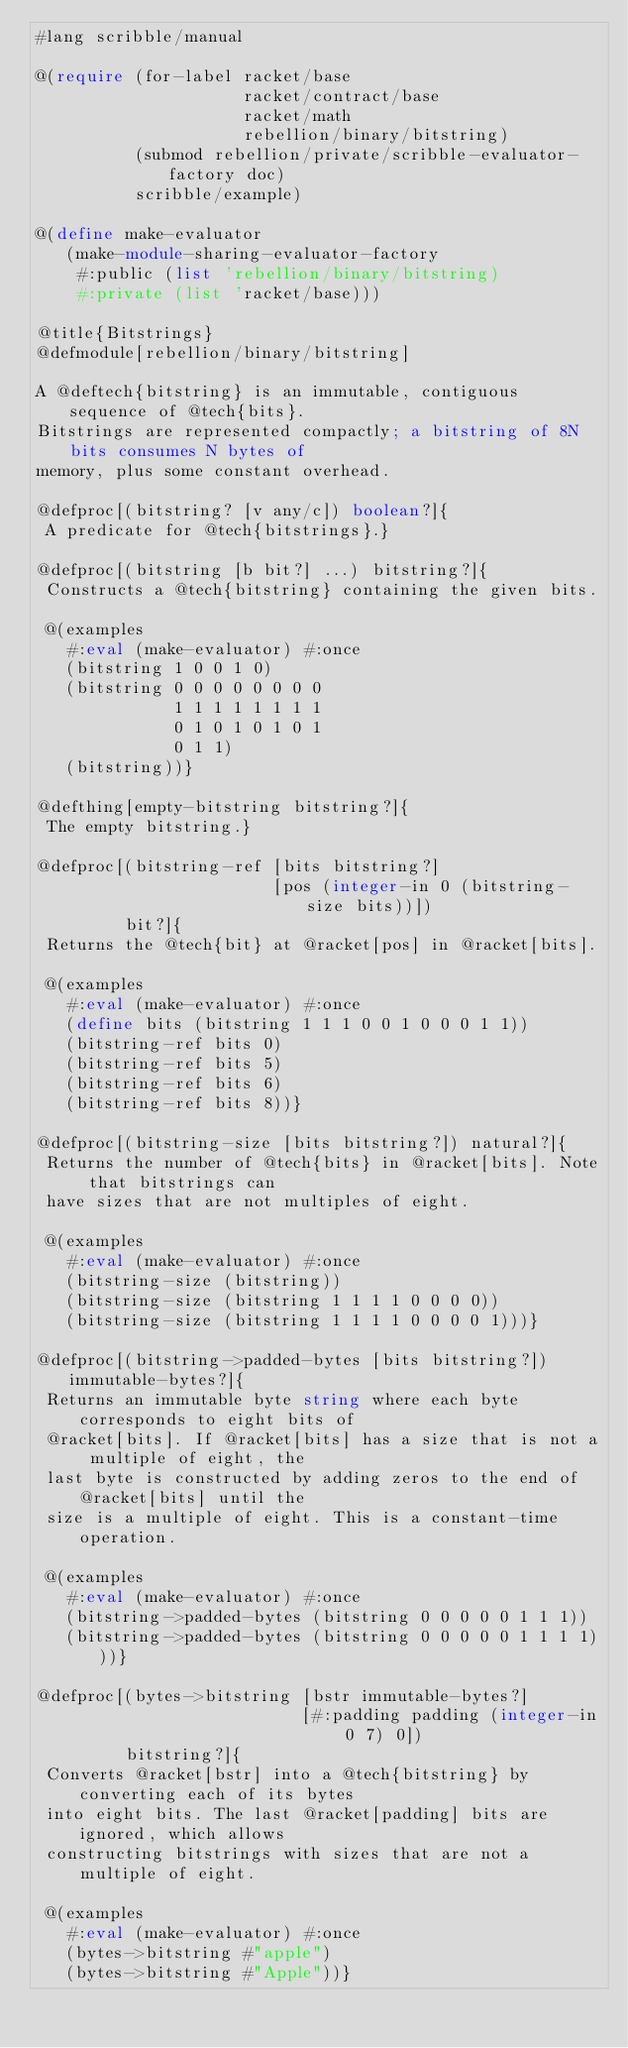Convert code to text. <code><loc_0><loc_0><loc_500><loc_500><_Racket_>#lang scribble/manual

@(require (for-label racket/base
                     racket/contract/base
                     racket/math
                     rebellion/binary/bitstring)
          (submod rebellion/private/scribble-evaluator-factory doc)
          scribble/example)

@(define make-evaluator
   (make-module-sharing-evaluator-factory
    #:public (list 'rebellion/binary/bitstring)
    #:private (list 'racket/base)))

@title{Bitstrings}
@defmodule[rebellion/binary/bitstring]

A @deftech{bitstring} is an immutable, contiguous sequence of @tech{bits}.
Bitstrings are represented compactly; a bitstring of 8N bits consumes N bytes of
memory, plus some constant overhead.

@defproc[(bitstring? [v any/c]) boolean?]{
 A predicate for @tech{bitstrings}.}

@defproc[(bitstring [b bit?] ...) bitstring?]{
 Constructs a @tech{bitstring} containing the given bits.

 @(examples
   #:eval (make-evaluator) #:once
   (bitstring 1 0 0 1 0)
   (bitstring 0 0 0 0 0 0 0 0
              1 1 1 1 1 1 1 1
              0 1 0 1 0 1 0 1
              0 1 1)
   (bitstring))}

@defthing[empty-bitstring bitstring?]{
 The empty bitstring.}

@defproc[(bitstring-ref [bits bitstring?]
                        [pos (integer-in 0 (bitstring-size bits))])
         bit?]{
 Returns the @tech{bit} at @racket[pos] in @racket[bits].

 @(examples
   #:eval (make-evaluator) #:once
   (define bits (bitstring 1 1 1 0 0 1 0 0 0 1 1))
   (bitstring-ref bits 0)
   (bitstring-ref bits 5)
   (bitstring-ref bits 6)
   (bitstring-ref bits 8))}

@defproc[(bitstring-size [bits bitstring?]) natural?]{
 Returns the number of @tech{bits} in @racket[bits]. Note that bitstrings can
 have sizes that are not multiples of eight.

 @(examples
   #:eval (make-evaluator) #:once
   (bitstring-size (bitstring))
   (bitstring-size (bitstring 1 1 1 1 0 0 0 0))
   (bitstring-size (bitstring 1 1 1 1 0 0 0 0 1)))}

@defproc[(bitstring->padded-bytes [bits bitstring?]) immutable-bytes?]{
 Returns an immutable byte string where each byte corresponds to eight bits of
 @racket[bits]. If @racket[bits] has a size that is not a multiple of eight, the
 last byte is constructed by adding zeros to the end of @racket[bits] until the
 size is a multiple of eight. This is a constant-time operation.

 @(examples
   #:eval (make-evaluator) #:once
   (bitstring->padded-bytes (bitstring 0 0 0 0 0 1 1 1))
   (bitstring->padded-bytes (bitstring 0 0 0 0 0 1 1 1 1)))}

@defproc[(bytes->bitstring [bstr immutable-bytes?]
                           [#:padding padding (integer-in 0 7) 0])
         bitstring?]{
 Converts @racket[bstr] into a @tech{bitstring} by converting each of its bytes
 into eight bits. The last @racket[padding] bits are ignored, which allows
 constructing bitstrings with sizes that are not a multiple of eight.

 @(examples
   #:eval (make-evaluator) #:once
   (bytes->bitstring #"apple")
   (bytes->bitstring #"Apple"))}
</code> 